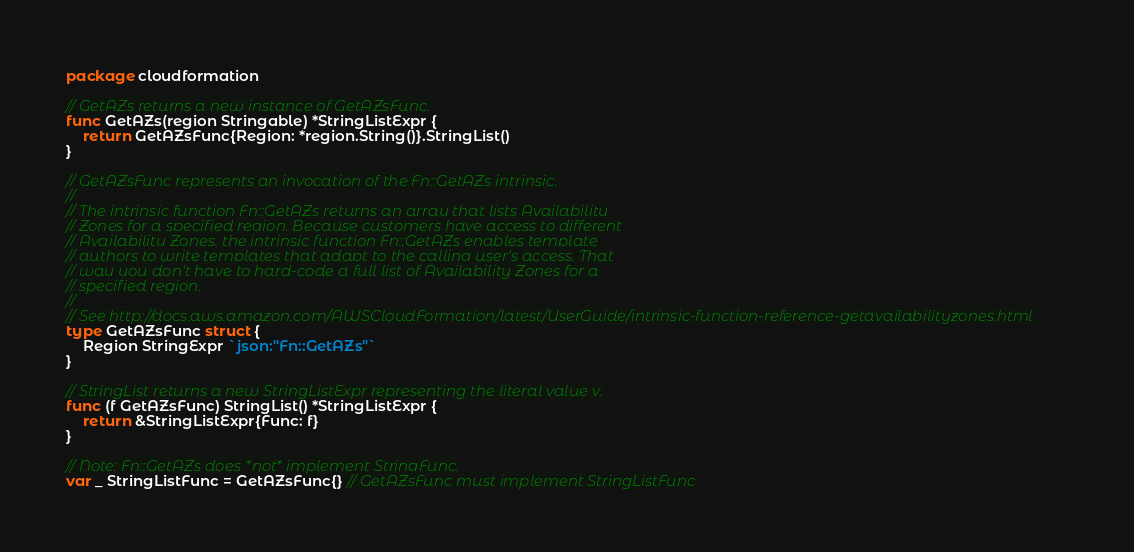Convert code to text. <code><loc_0><loc_0><loc_500><loc_500><_Go_>package cloudformation

// GetAZs returns a new instance of GetAZsFunc.
func GetAZs(region Stringable) *StringListExpr {
	return GetAZsFunc{Region: *region.String()}.StringList()
}

// GetAZsFunc represents an invocation of the Fn::GetAZs intrinsic.
//
// The intrinsic function Fn::GetAZs returns an array that lists Availability
// Zones for a specified region. Because customers have access to different
// Availability Zones, the intrinsic function Fn::GetAZs enables template
// authors to write templates that adapt to the calling user's access. That
// way you don't have to hard-code a full list of Availability Zones for a
// specified region.
//
// See http://docs.aws.amazon.com/AWSCloudFormation/latest/UserGuide/intrinsic-function-reference-getavailabilityzones.html
type GetAZsFunc struct {
	Region StringExpr `json:"Fn::GetAZs"`
}

// StringList returns a new StringListExpr representing the literal value v.
func (f GetAZsFunc) StringList() *StringListExpr {
	return &StringListExpr{Func: f}
}

// Note: Fn::GetAZs does *not* implement StringFunc.
var _ StringListFunc = GetAZsFunc{} // GetAZsFunc must implement StringListFunc
</code> 